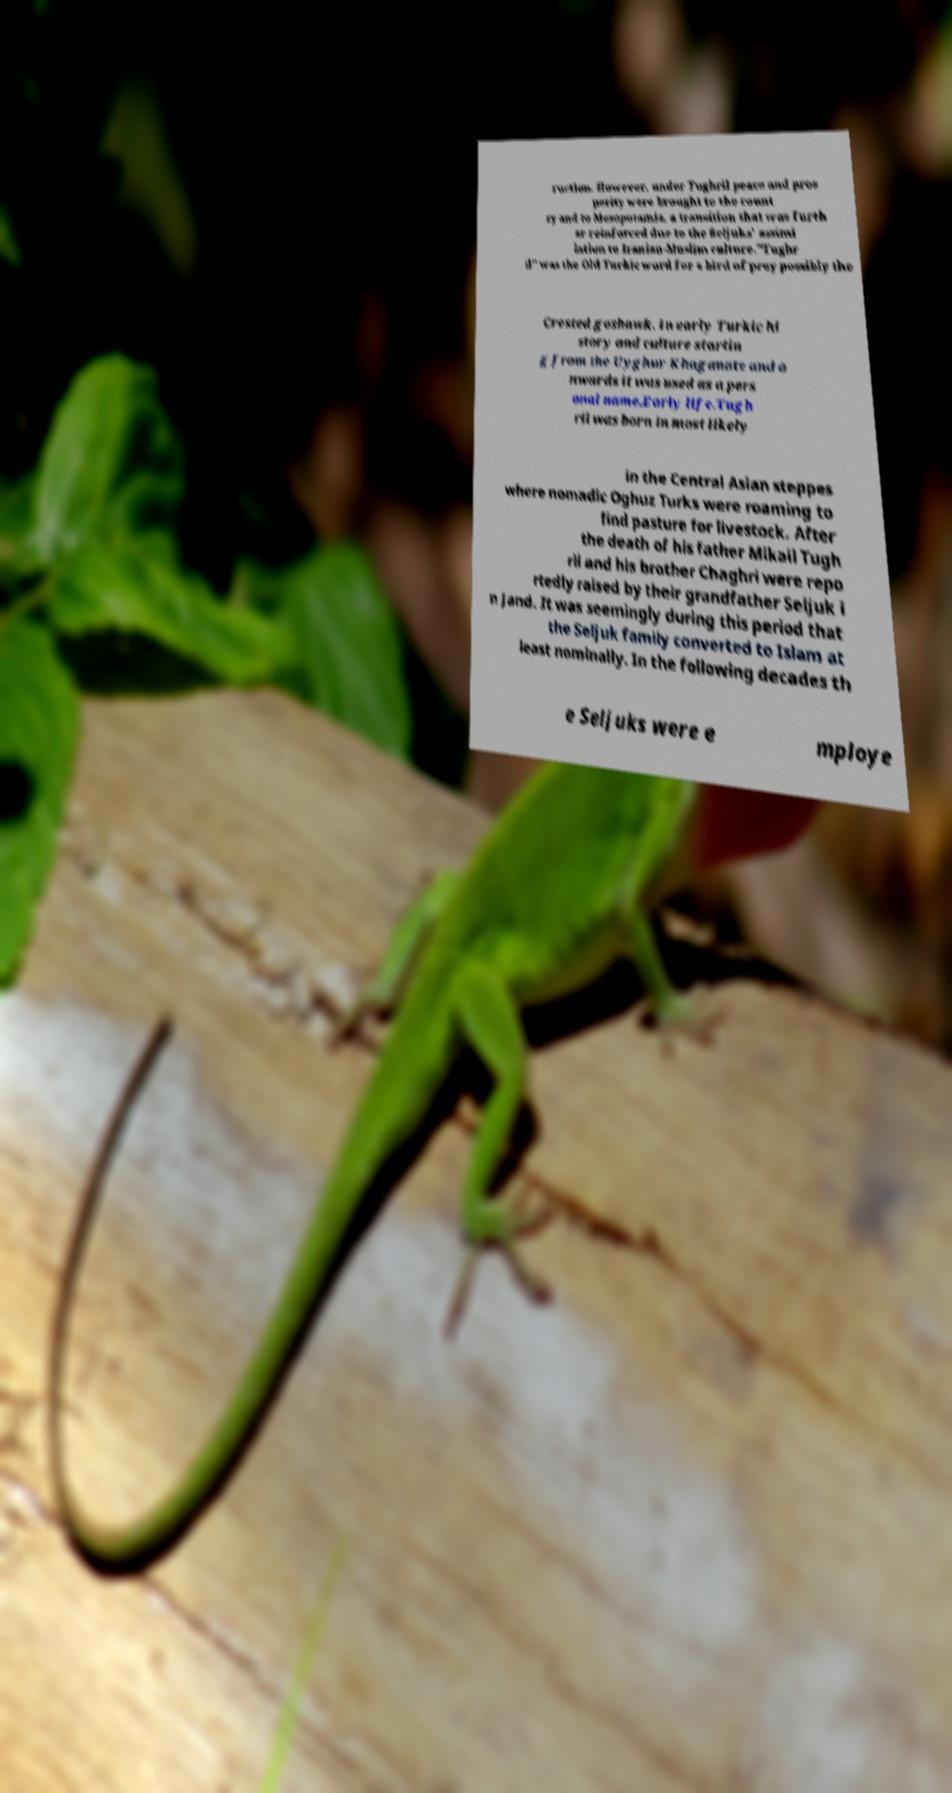For documentation purposes, I need the text within this image transcribed. Could you provide that? ruction. However, under Tughril peace and pros perity were brought to the count ry and to Mesopotamia, a transition that was furth er reinforced due to the Seljuks' assimi lation to Iranian-Muslim culture."Tughr il" was the Old Turkic word for a bird of prey possibly the Crested goshawk. In early Turkic hi story and culture startin g from the Uyghur Khaganate and o nwards it was used as a pers onal name.Early life.Tugh ril was born in most likely in the Central Asian steppes where nomadic Oghuz Turks were roaming to find pasture for livestock. After the death of his father Mikail Tugh ril and his brother Chaghri were repo rtedly raised by their grandfather Seljuk i n Jand. It was seemingly during this period that the Seljuk family converted to Islam at least nominally. In the following decades th e Seljuks were e mploye 